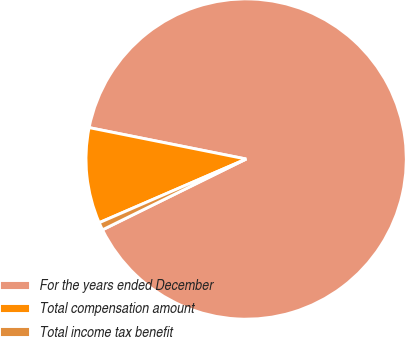Convert chart to OTSL. <chart><loc_0><loc_0><loc_500><loc_500><pie_chart><fcel>For the years ended December<fcel>Total compensation amount<fcel>Total income tax benefit<nl><fcel>89.57%<fcel>9.65%<fcel>0.78%<nl></chart> 